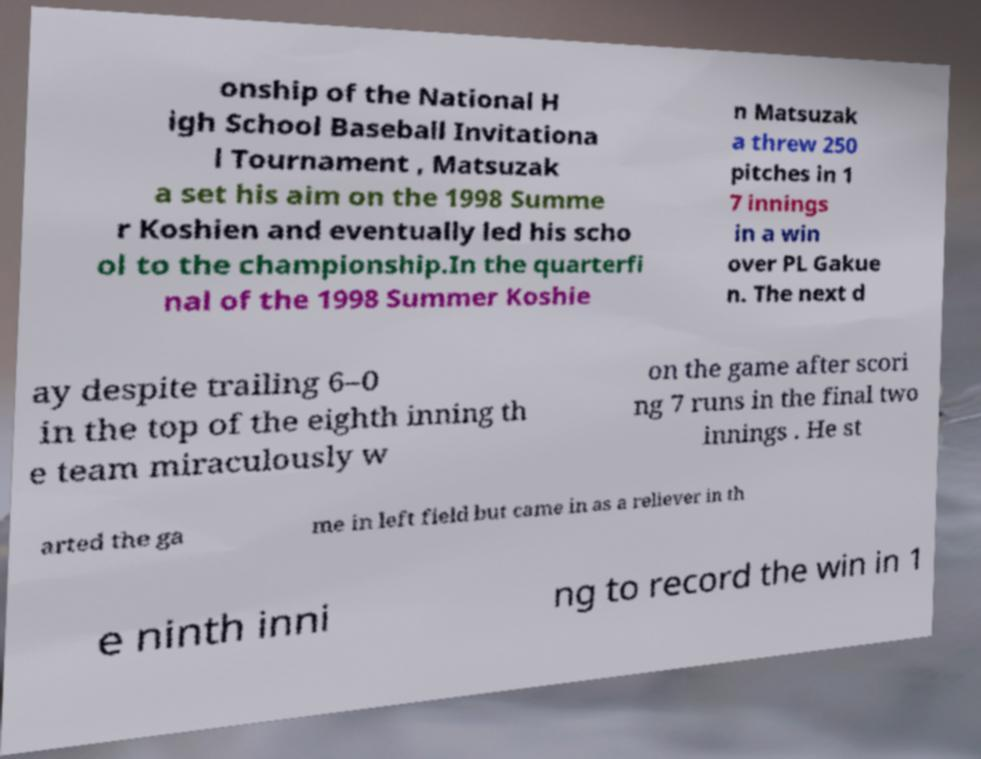Please read and relay the text visible in this image. What does it say? onship of the National H igh School Baseball Invitationa l Tournament , Matsuzak a set his aim on the 1998 Summe r Koshien and eventually led his scho ol to the championship.In the quarterfi nal of the 1998 Summer Koshie n Matsuzak a threw 250 pitches in 1 7 innings in a win over PL Gakue n. The next d ay despite trailing 6–0 in the top of the eighth inning th e team miraculously w on the game after scori ng 7 runs in the final two innings . He st arted the ga me in left field but came in as a reliever in th e ninth inni ng to record the win in 1 